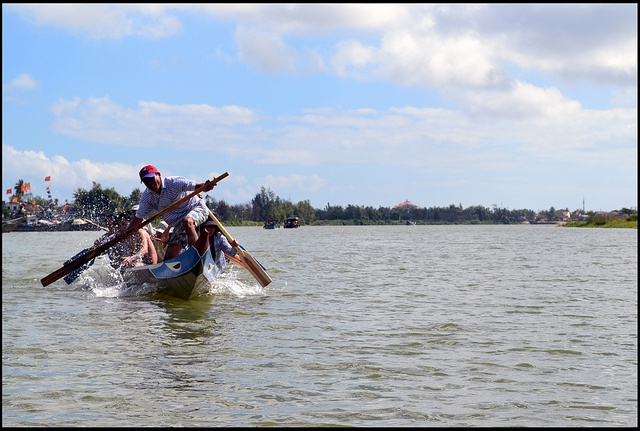Describe the objects in this image and their specific colors. I can see people in black, navy, purple, and maroon tones, boat in black, navy, gray, and darkgray tones, people in black, lightpink, gray, and maroon tones, people in black, gray, and darkgray tones, and people in black, navy, gray, and darkgray tones in this image. 